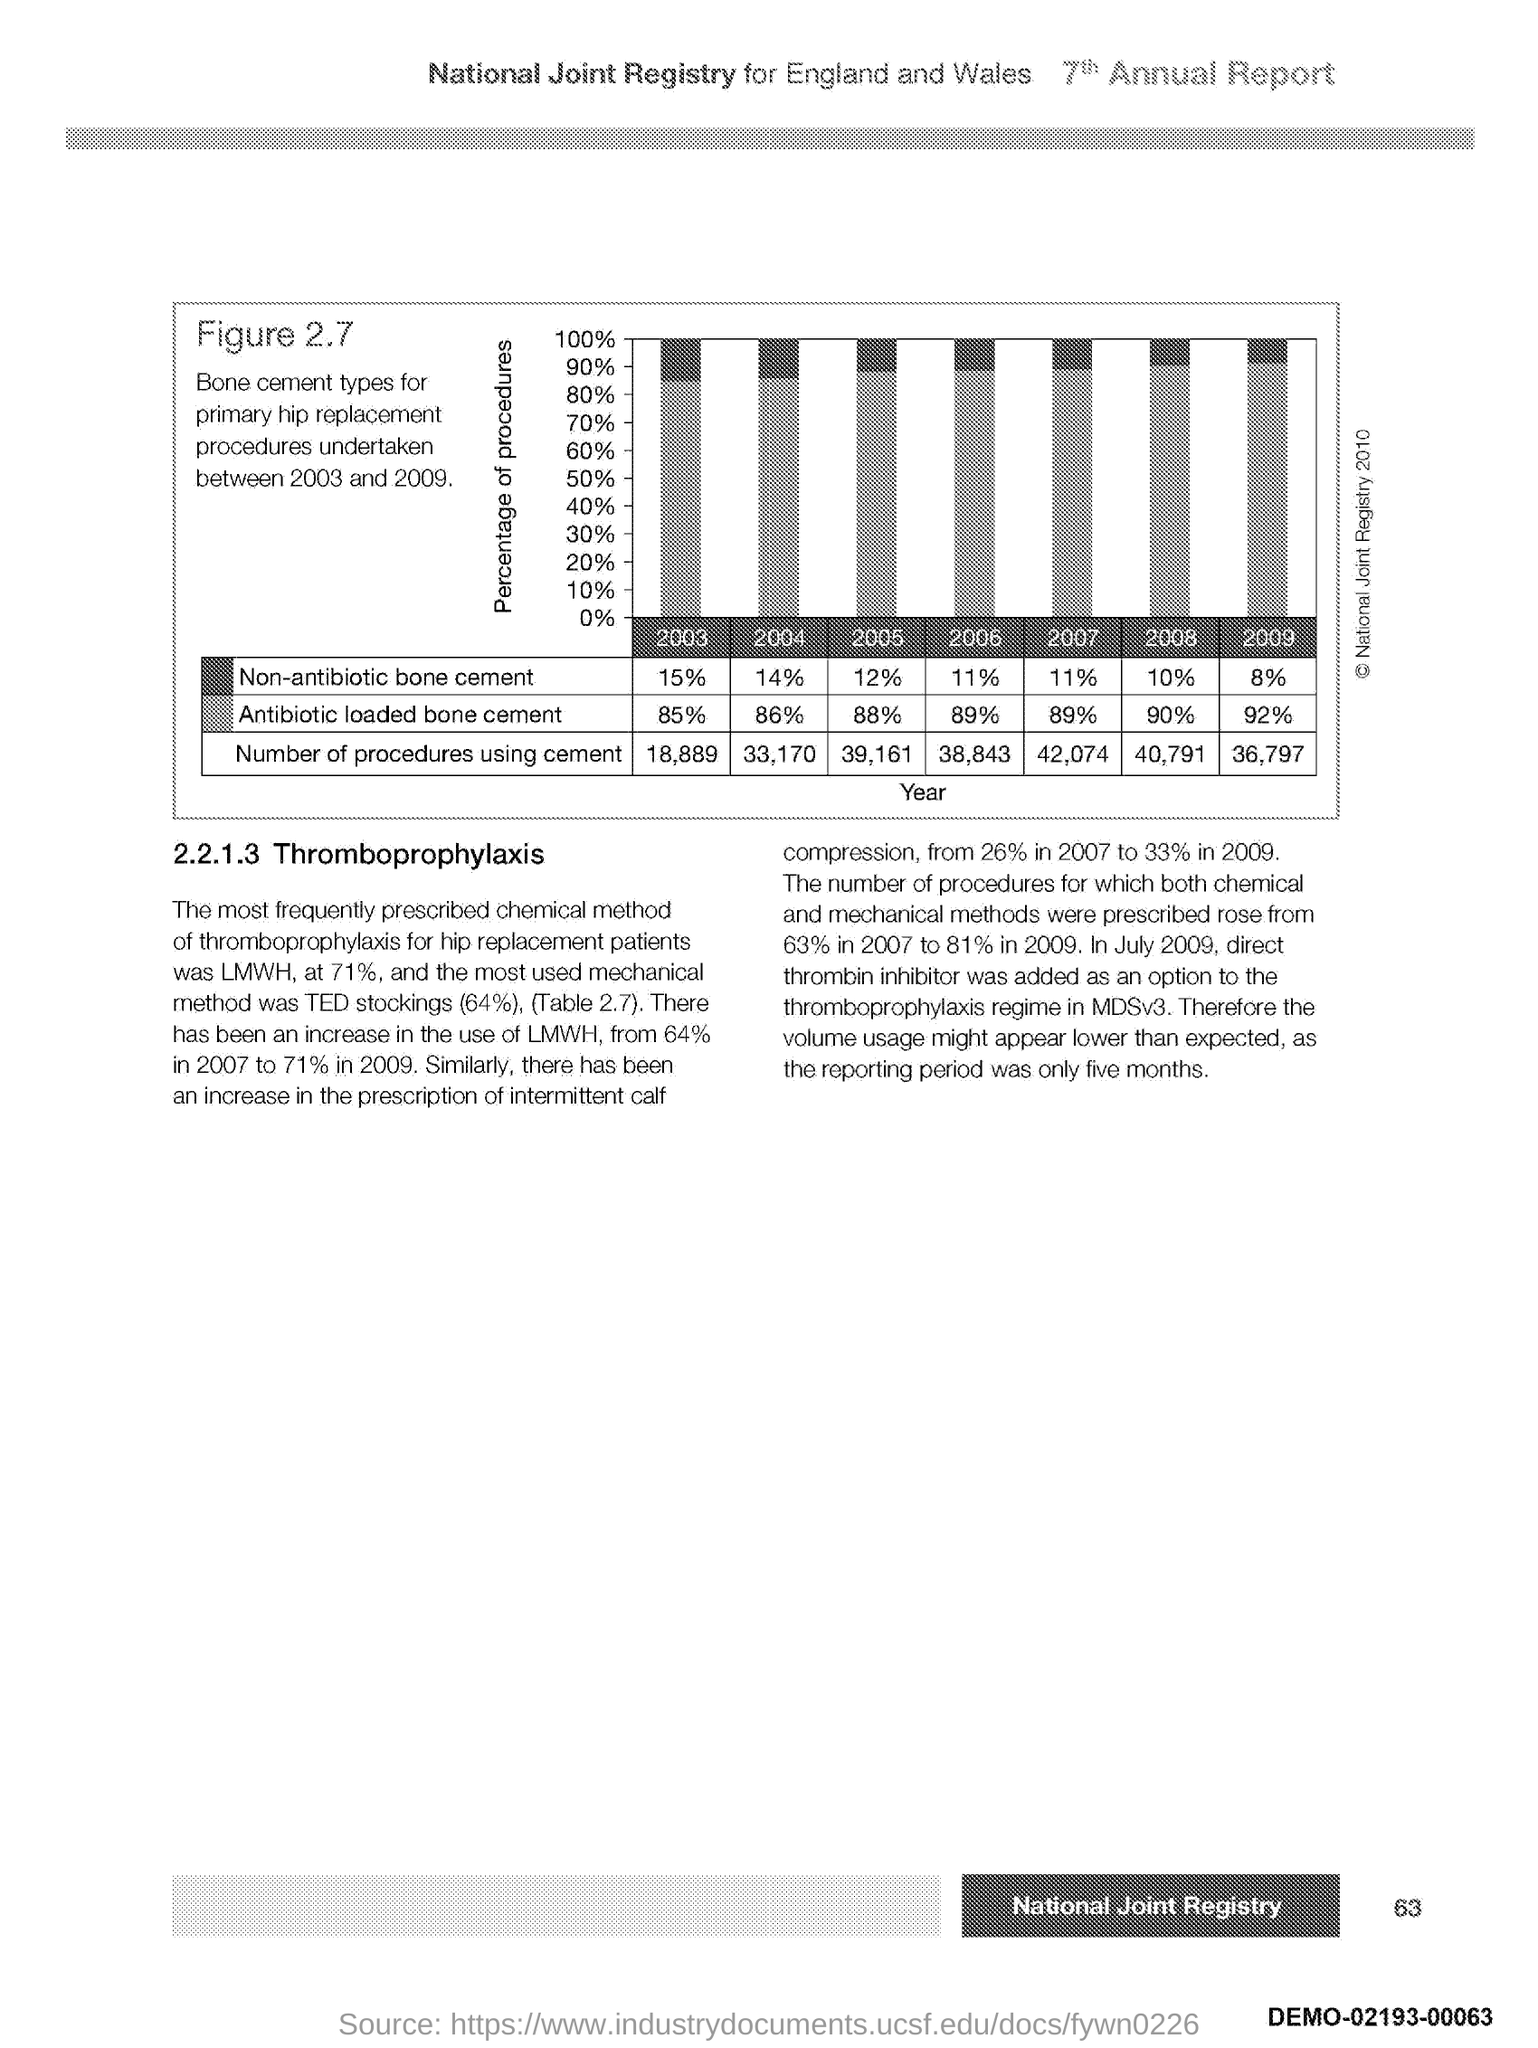Which are the 2 countries mentioned in the title of the page?
Ensure brevity in your answer.  England and Wales. What is the heading of section 2.2.1.3?
Offer a terse response. Thromboprophylaxis. What is shown in Figure 2.7?
Your answer should be compact. Bone cement types. As per the Figure 2.7, How many procedures were done using cement in the year 2009?
Offer a terse response. 36,797. As per the Figure 2.7, How many procedures were done using cement in the year 2005?
Your response must be concise. 39,161. As per the Figure 2.7, what % of Antibiotic loaded bone cement was used in the year 2003?
Offer a terse response. 85%. As per the Figure 2.7, what % of Antibiotic loaded bone cement was used in the year 2007?
Your answer should be compact. 89%. As per the Figure 2.7, what % of Non-antibiotic bone cement was used in the year 2004?
Give a very brief answer. 14. What is shown on the vertical axis of the graph in Figure 2.7?
Keep it short and to the point. Percentage of procedures. As per the Figure 2.7, what % of Non-antibiotic bone cement was used in the year 2008?
Keep it short and to the point. 10%. 